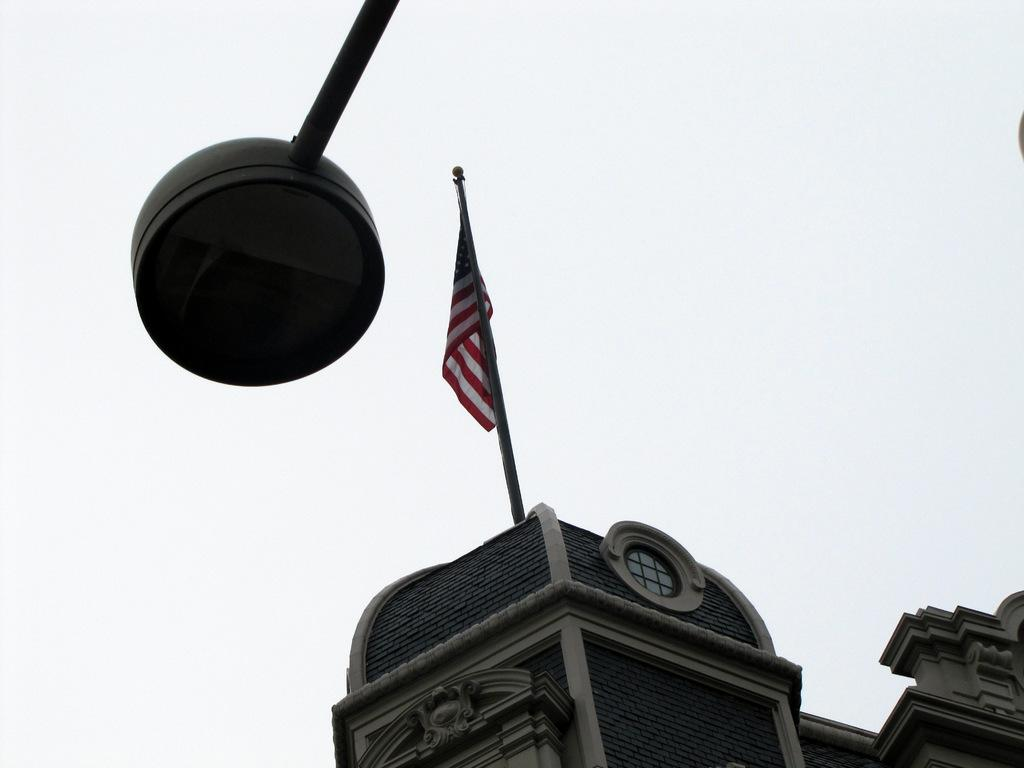What is located on the left side of the image? There is a pole light on the left side of the image. What can be seen in the background of the image? There are buildings and a flag in the background of the image. How much profit does the tiger make from the door in the image? There is no tiger or door present in the image, so it is not possible to determine any profit. 